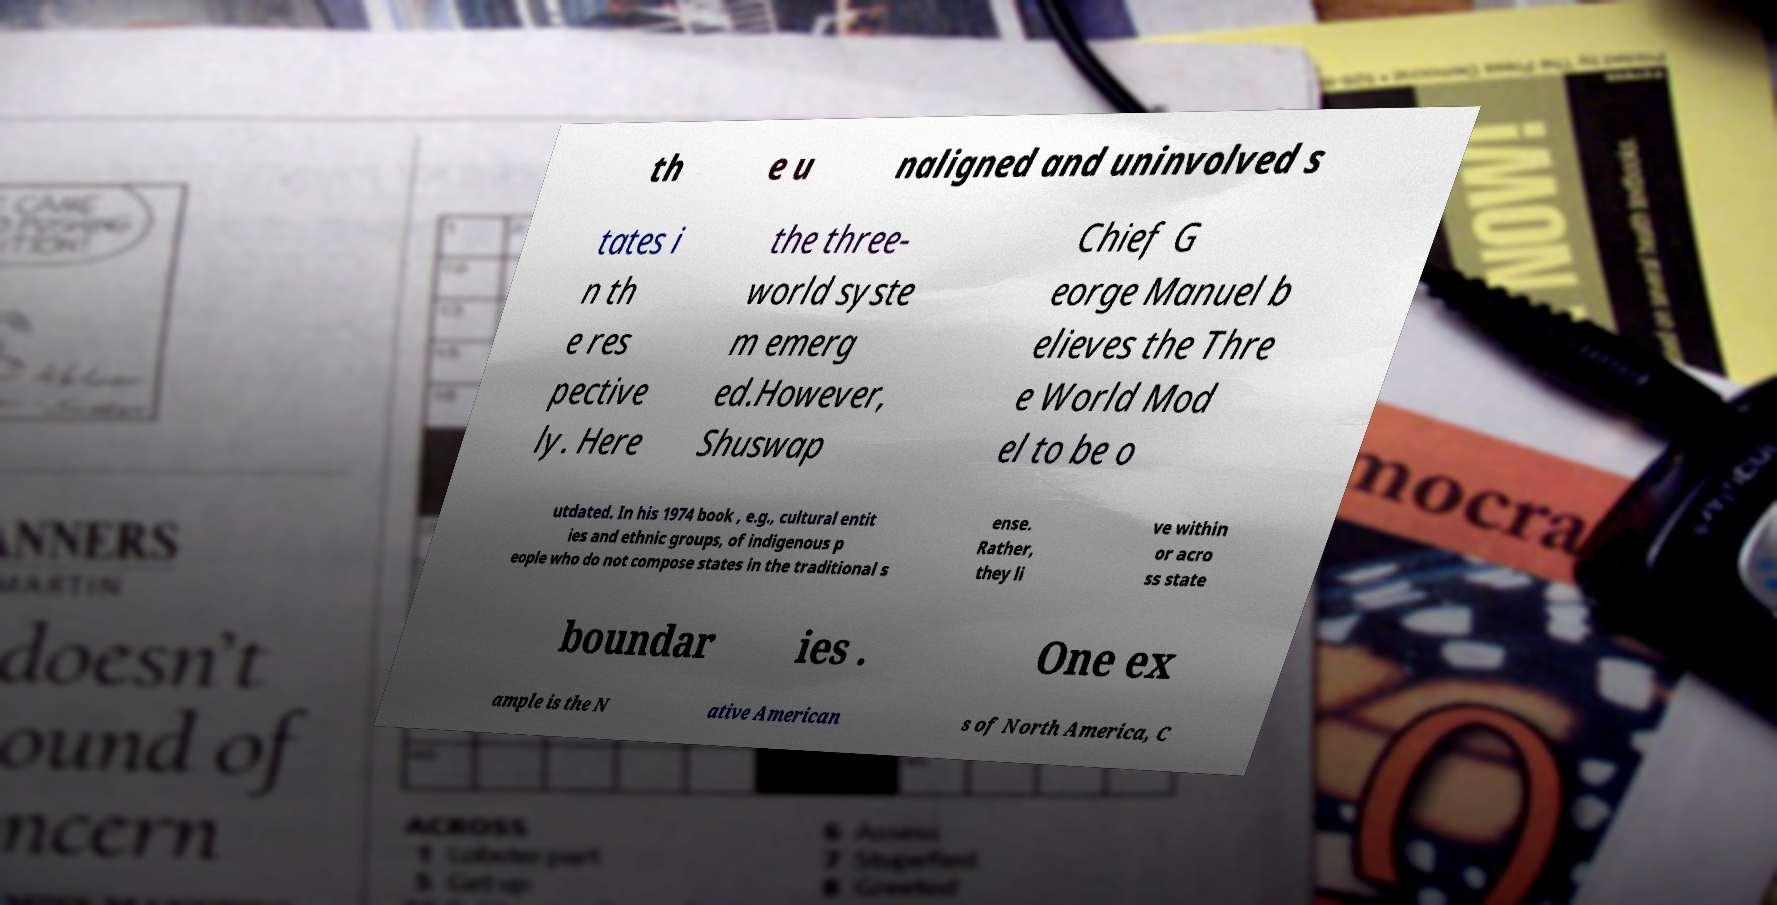Can you read and provide the text displayed in the image?This photo seems to have some interesting text. Can you extract and type it out for me? th e u naligned and uninvolved s tates i n th e res pective ly. Here the three- world syste m emerg ed.However, Shuswap Chief G eorge Manuel b elieves the Thre e World Mod el to be o utdated. In his 1974 book , e.g., cultural entit ies and ethnic groups, of indigenous p eople who do not compose states in the traditional s ense. Rather, they li ve within or acro ss state boundar ies . One ex ample is the N ative American s of North America, C 